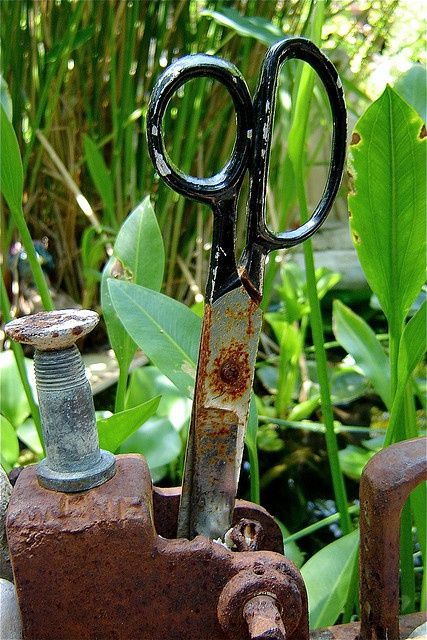Describe the objects in this image and their specific colors. I can see scissors in darkgreen, black, and gray tones in this image. 